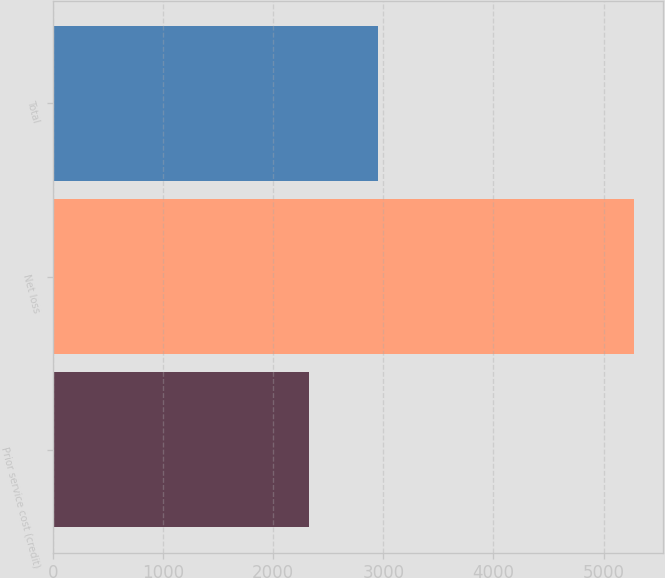<chart> <loc_0><loc_0><loc_500><loc_500><bar_chart><fcel>Prior service cost (credit)<fcel>Net loss<fcel>Total<nl><fcel>2325<fcel>5279<fcel>2954<nl></chart> 